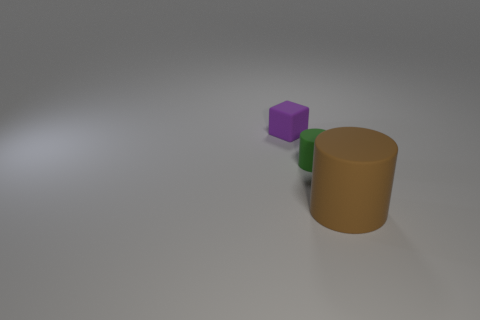Subtract all blue cylinders. Subtract all green spheres. How many cylinders are left? 2 Subtract all cyan cubes. How many cyan cylinders are left? 0 Add 1 big yellows. How many things exist? 0 Subtract all green rubber cylinders. Subtract all green rubber things. How many objects are left? 1 Add 2 tiny blocks. How many tiny blocks are left? 3 Add 1 tiny green rubber things. How many tiny green rubber things exist? 2 Add 1 tiny green things. How many objects exist? 4 Subtract all green cylinders. How many cylinders are left? 1 Subtract 0 red balls. How many objects are left? 3 Subtract all cylinders. How many objects are left? 1 